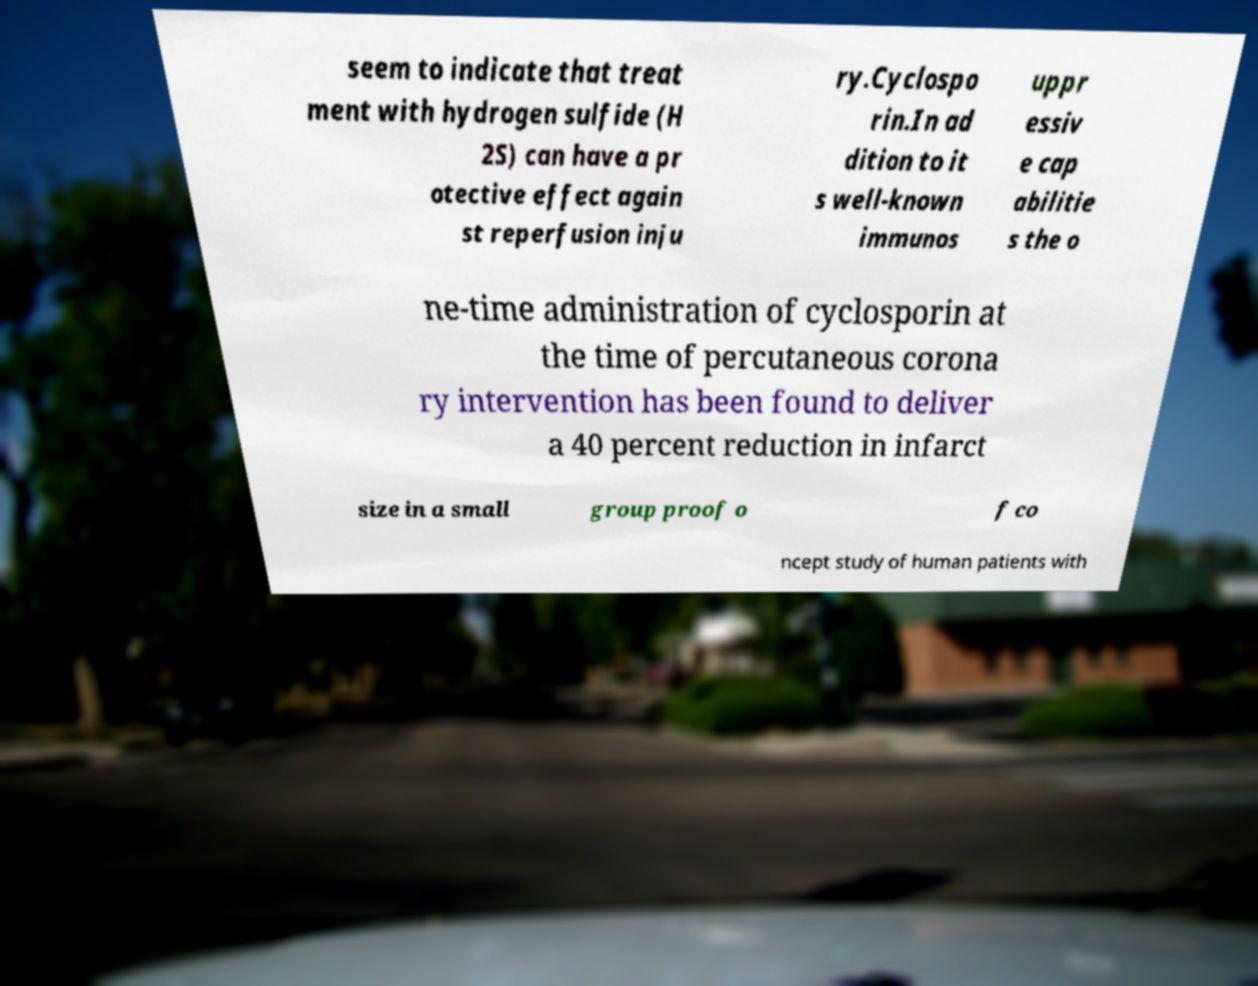What messages or text are displayed in this image? I need them in a readable, typed format. seem to indicate that treat ment with hydrogen sulfide (H 2S) can have a pr otective effect again st reperfusion inju ry.Cyclospo rin.In ad dition to it s well-known immunos uppr essiv e cap abilitie s the o ne-time administration of cyclosporin at the time of percutaneous corona ry intervention has been found to deliver a 40 percent reduction in infarct size in a small group proof o f co ncept study of human patients with 